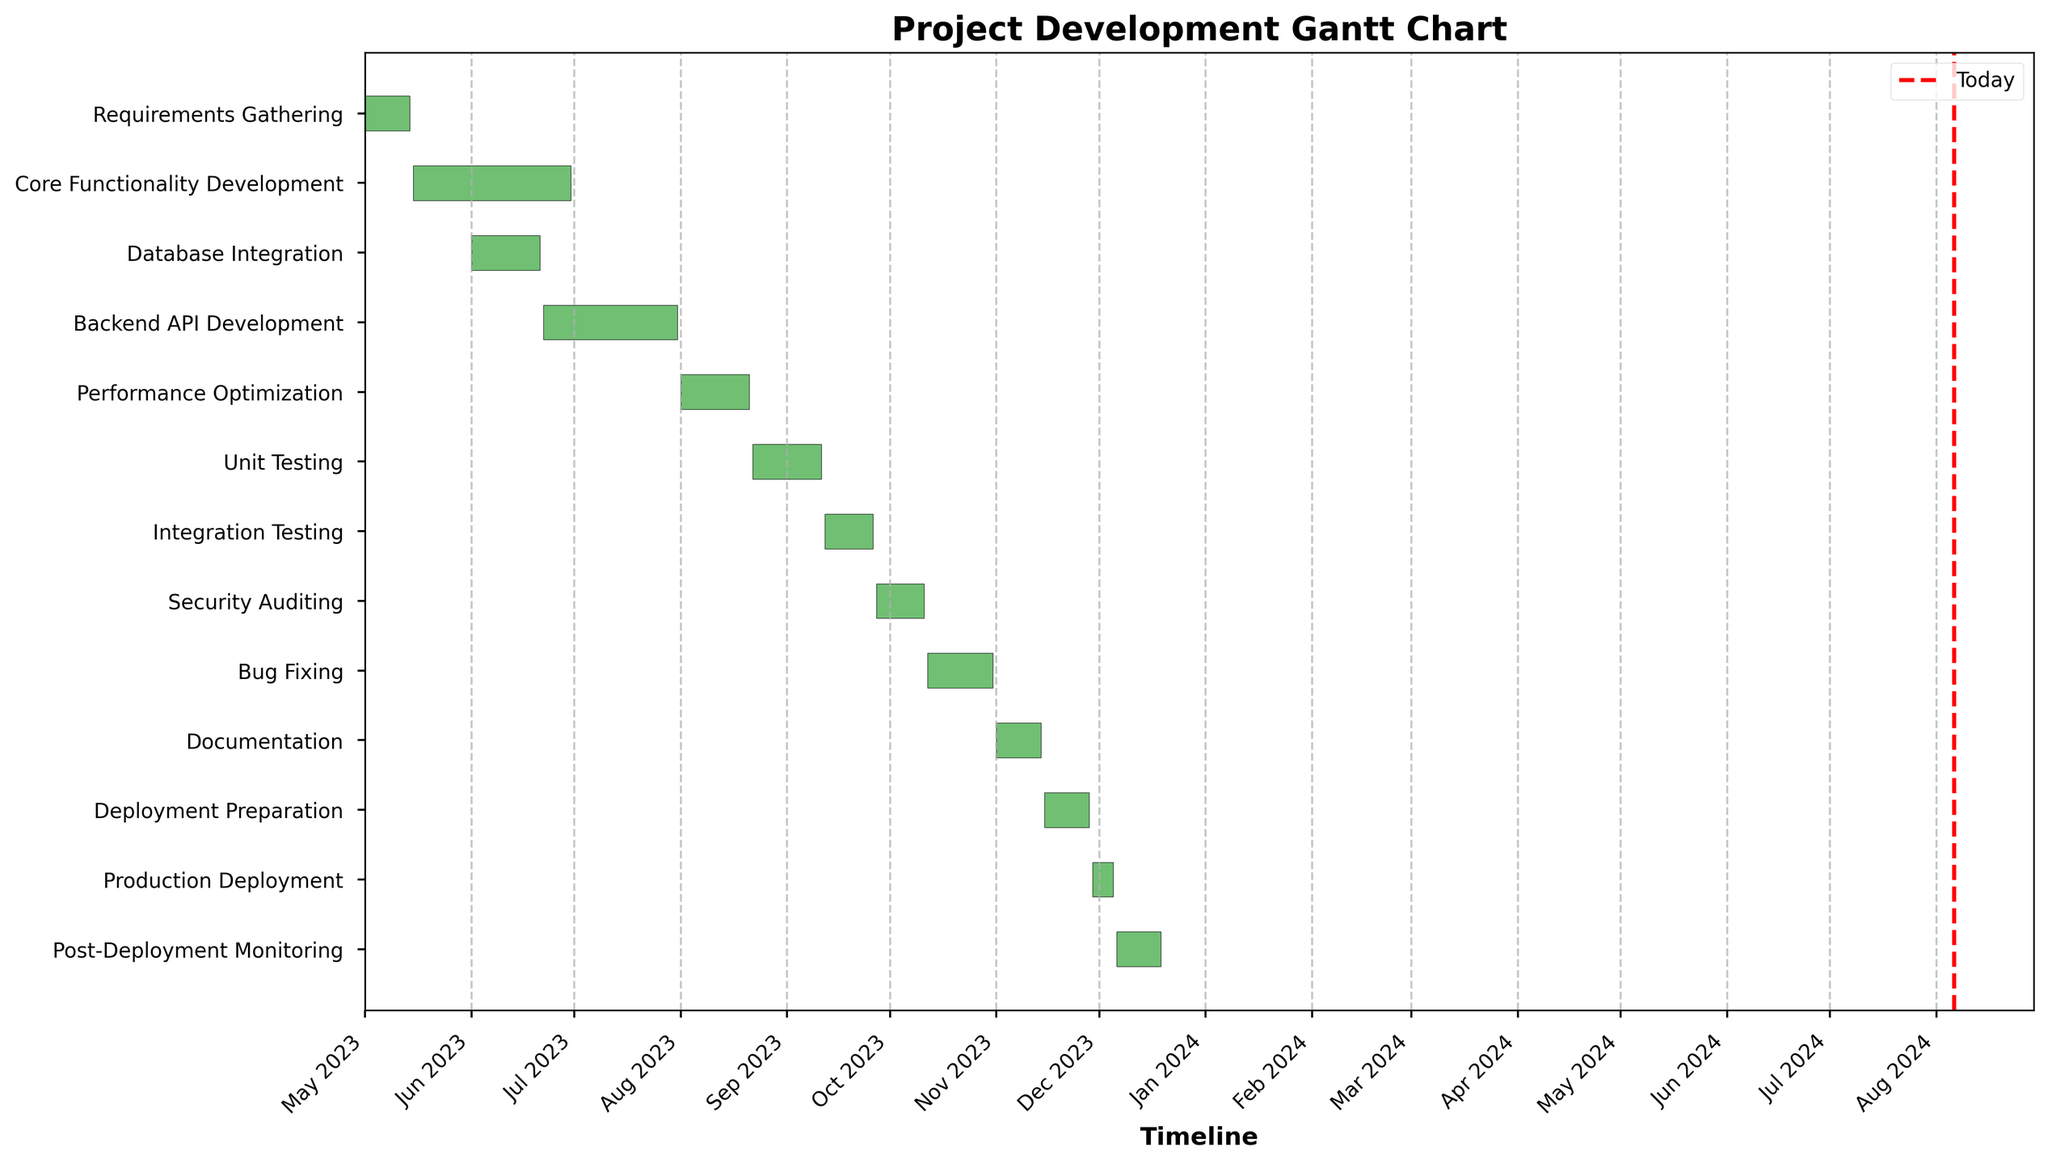What is the title of the chart? The title of the chart is shown at the top of the figure. The title reads, "Project Development Gantt Chart".
Answer: Project Development Gantt Chart What is the color used for the horizontal bars in the chart? The horizontal bars in the chart are colored in a shade of green.
Answer: Green How many tasks are there from Requirements Gathering to Post-Deployment Monitoring? We count the number of tasks listed on the y-axis from "Requirements Gathering" to "Post-Deployment Monitoring".
Answer: 13 Which task has the longest duration? To determine the longest duration, we look at the horizontal bars and compare their lengths. The longest bar represents the task with the longest duration. "Core Functionality Development" has the longest bar.
Answer: Core Functionality Development Which task starts immediately after "Core Functionality Development"? We identify the end date of "Core Functionality Development" and find the task that begins the day after. "Backend API Development" starts after it.
Answer: Backend API Development What is the total duration for the combination of "Unit Testing" and "Integration Testing"? We find the durations for "Unit Testing" (21 days) and "Integration Testing" (15 days), then add them together.
Answer: 36 days How many tasks have a duration of exactly 21 days? We count the tasks with a horizontal bar of the same length, specifically those labeled "Database Integration", "Performance Optimization", and "Unit Testing".
Answer: 3 Which task overlaps with both "Unit Testing" and "Integration Testing"? "Security Auditing" starts on 2023-09-27, during the end of "Unit Testing" and the beginning of "Integration Testing". "Security Auditing" overlaps with both tasks.
Answer: Security Auditing What is the duration of all tasks starting from "Performance Optimization" to "Documentation"? We sum the durations of the tasks: Performance Optimization (21 days), Unit Testing (21 days), Integration Testing (15 days), Security Auditing (15 days), Bug Fixing (20 days), and Documentation (14 days). 21 + 21 + 15 + 15 + 20 + 14 = 106 days.
Answer: 106 days Which tasks are still ahead of today's date? We check the current date and compare it to the start and end dates of each task. As of today, the tasks "Documentation", "Deployment Preparation", "Production Deployment", and "Post-Deployment Monitoring" are still ahead.
Answer: Documentation, Deployment Preparation, Production Deployment, Post-Deployment Monitoring 